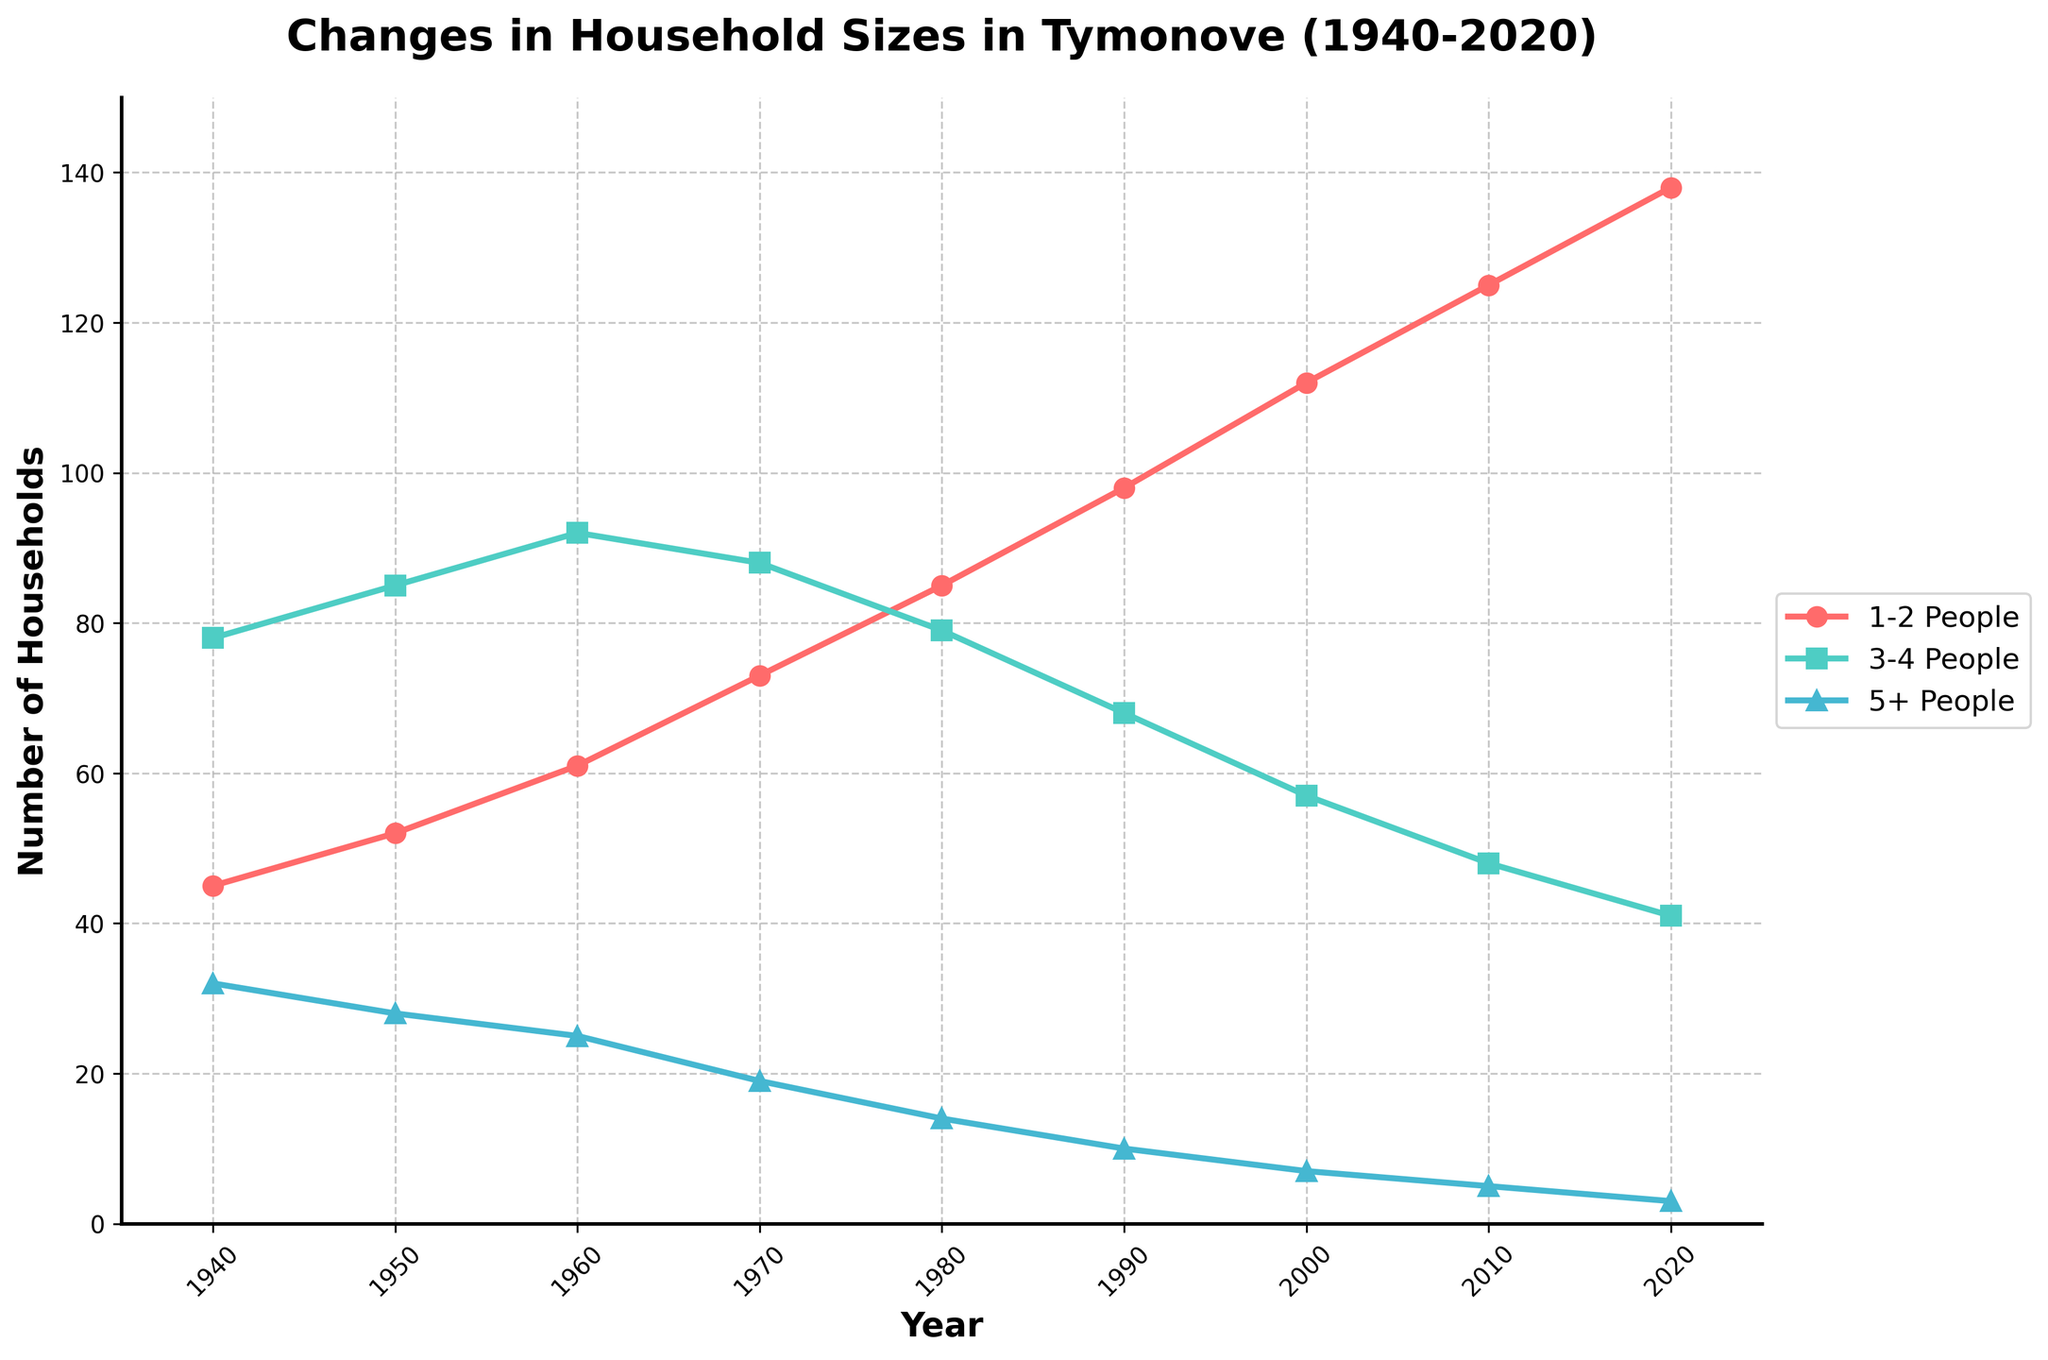What trend can we see in the number of households with 1-2 people over the years? Starting from 1940, the number of households with 1-2 people consistently increased. In 1940, there were 45 households and by 2020, this number had risen to 138. This shows a steady upward trend.
Answer: Steady increase Which household size category was the largest in 1960? In 1960, the number of households was: 1-2 People: 61, 3-4 People: 92, 5+ People: 25. The largest category was 3-4 People with 92 households.
Answer: 3-4 People How did the number of households with 5+ people change from 1940 to 2020? The number of households with 5+ people decreased from 32 in 1940 to 3 in 2020. This reflects a reduction of 29 households over this period.
Answer: Decrease Between which consecutive decades did the 1-2 people household category see the greatest increase? To find the greatest increase, we calculate the differences for consecutive decades: 
1950-1940: 52-45 = 7,
1960-1950: 61-52 = 9,
1970-1960: 73-61 = 12,
1980-1970: 85-73 = 12,
1990-1980: 98-85 = 13,
2000-1990: 112-98 = 14,
2010-2000: 125-112 = 13,
2020-2010: 138-125 = 13.
The greatest increase was from 1990 to 2000, which is 14 households.
Answer: 1990 to 2000 How many households were there in total in Tymonove in 1980? To find the total, sum the households in each category for 1980: 
85 (1-2 People) + 79 (3-4 People) + 14 (5+ People) = 178.
Answer: 178 Which line color represents 3-4 people households, and how do we know? The 3-4 people households line is plotted in green, as the legend indicates green represents this category.
Answer: Green What happened to the number of households with 3-4 people from 1980 to 2000? From 1980 to 2000, the number of households with 3-4 people decreased from 79 to 57. This is a decrease of 22 households.
Answer: Decrease Overall, how did the total number of households change from 1940 to 2020? Summing the totals for both years:
1940: 45 (1-2 People) + 78 (3-4 People) + 32 (5+ People) = 155,
2020: 138 (1-2 People) + 41 (3-4 People) + 3 (5+ People) = 182.
The total number of households increased by 182 - 155 = 27.
Answer: Increased by 27 In which year did the 5+ people households category experience the sharpest decline? Observing the data, the sharpest decline is noticed between 1970 and 1980, where the number of households drops from 19 to 14, a decline of 5 households.
Answer: Between 1970 and 1980 Which year shows the lowest overall number of households with more than 5 people? Reviewing the data, 2020 shows the lowest number of households with more than 5 people, at 3 households.
Answer: 2020 